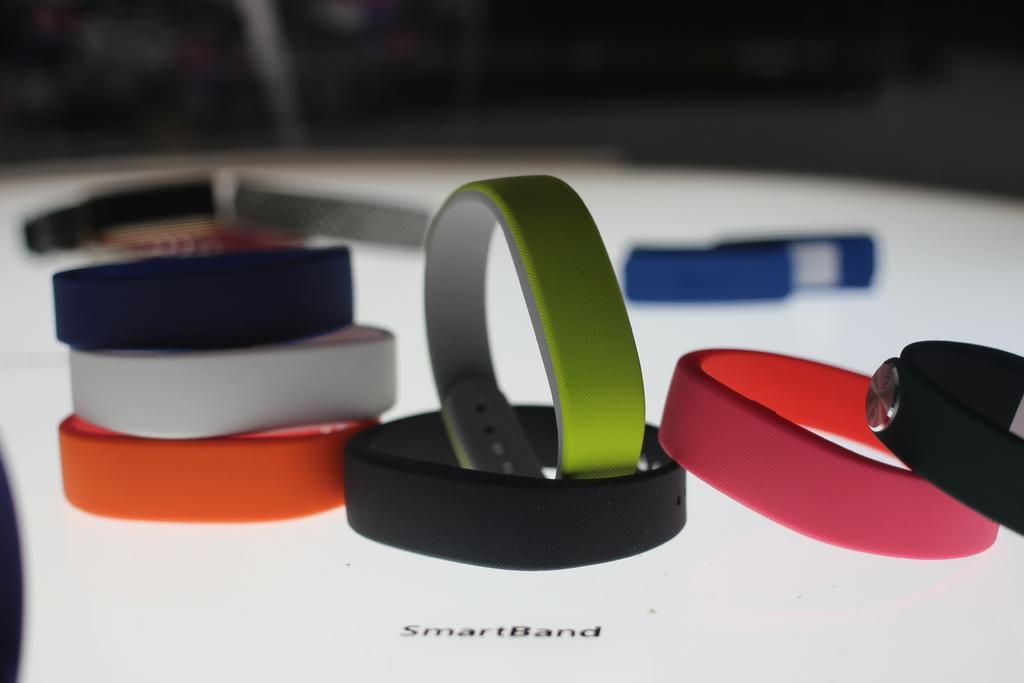Can you describe this image briefly? The picture consists of various colors of smart bands on a white surface. The background is blurred. 